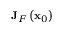<formula> <loc_0><loc_0><loc_500><loc_500>J _ { F } \left ( x _ { 0 } \right )</formula> 